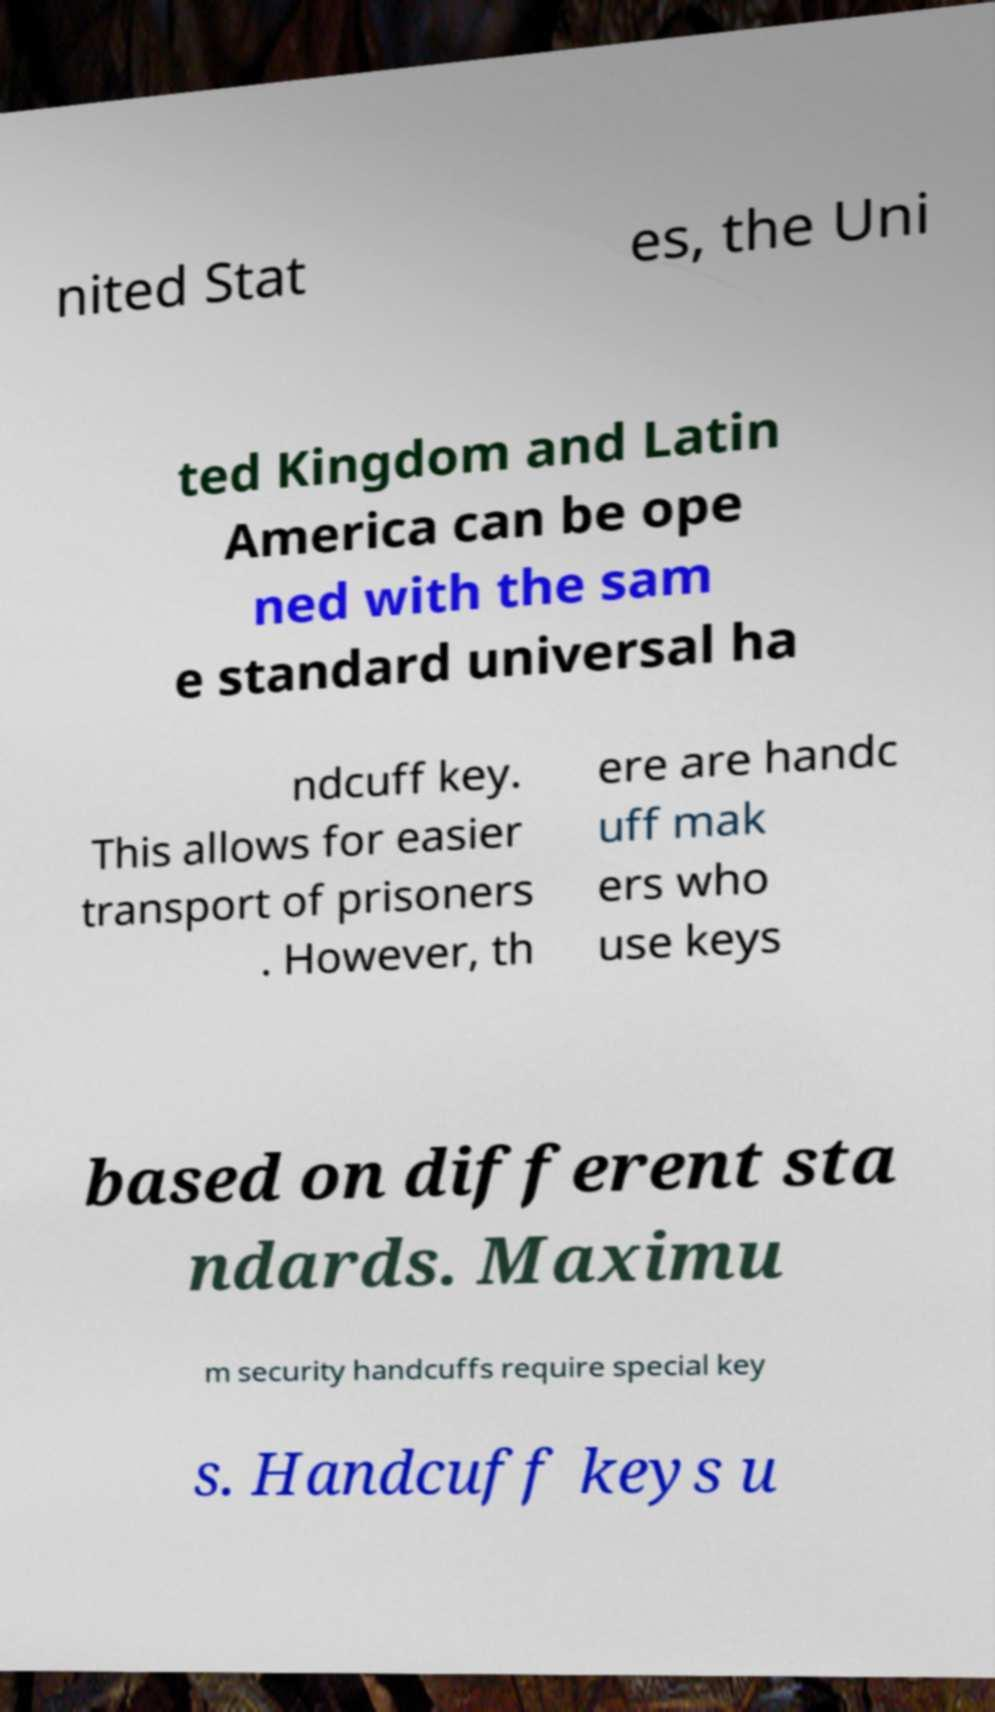Please read and relay the text visible in this image. What does it say? nited Stat es, the Uni ted Kingdom and Latin America can be ope ned with the sam e standard universal ha ndcuff key. This allows for easier transport of prisoners . However, th ere are handc uff mak ers who use keys based on different sta ndards. Maximu m security handcuffs require special key s. Handcuff keys u 